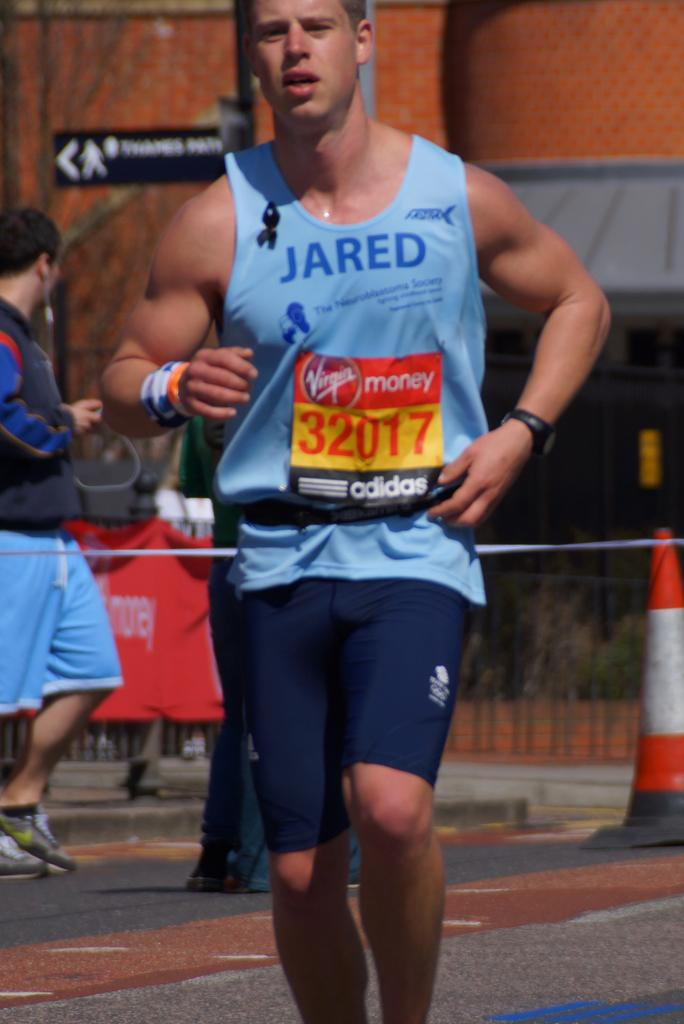<image>
Write a terse but informative summary of the picture. A marathon runner number 32017 in a blue tank top and blue shorts 